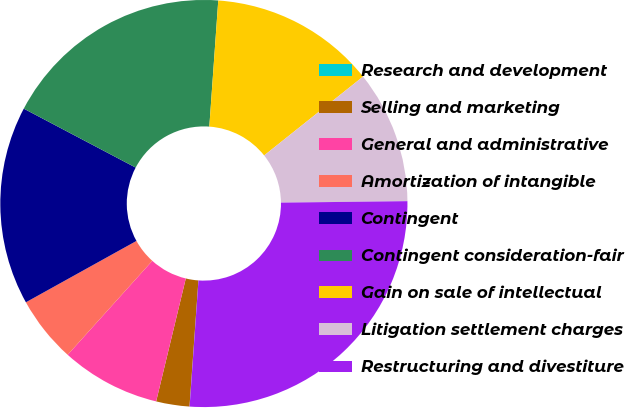Convert chart. <chart><loc_0><loc_0><loc_500><loc_500><pie_chart><fcel>Research and development<fcel>Selling and marketing<fcel>General and administrative<fcel>Amortization of intangible<fcel>Contingent<fcel>Contingent consideration-fair<fcel>Gain on sale of intellectual<fcel>Litigation settlement charges<fcel>Restructuring and divestiture<nl><fcel>0.01%<fcel>2.64%<fcel>7.9%<fcel>5.27%<fcel>15.78%<fcel>18.41%<fcel>13.16%<fcel>10.53%<fcel>26.3%<nl></chart> 